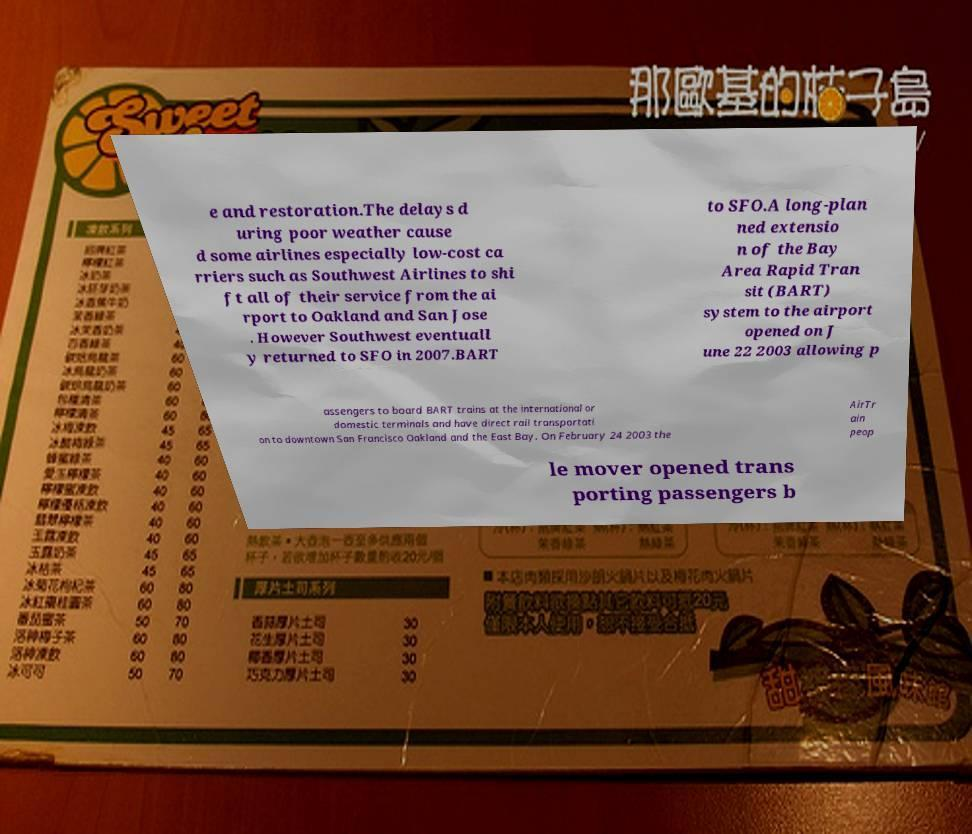Could you extract and type out the text from this image? e and restoration.The delays d uring poor weather cause d some airlines especially low-cost ca rriers such as Southwest Airlines to shi ft all of their service from the ai rport to Oakland and San Jose . However Southwest eventuall y returned to SFO in 2007.BART to SFO.A long-plan ned extensio n of the Bay Area Rapid Tran sit (BART) system to the airport opened on J une 22 2003 allowing p assengers to board BART trains at the international or domestic terminals and have direct rail transportati on to downtown San Francisco Oakland and the East Bay. On February 24 2003 the AirTr ain peop le mover opened trans porting passengers b 